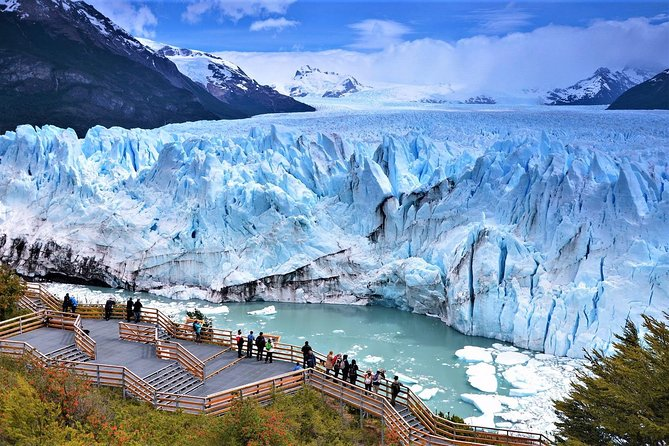What do you see happening in this image? The image provides a stunning view of the Perito Moreno Glacier in El Calafate, Argentina. This glacier is renowned for its remarkable expanse and vibrant blue color, characteristics that are beautifully captured here. From this elevated viewpoint, you can see tourists on a wooden viewing platform, dwarfed by the glacier's immense front wall. These tourists provide a sense of scale to the grandeur of the glacier. Above, the sky is mildly overcast, casting a soft, diffuse light that enhances the icy blue tones of the glacier. This scene not only captures natural beauty but also illustrates the interaction between humans and awe-inspiring natural wonders. 